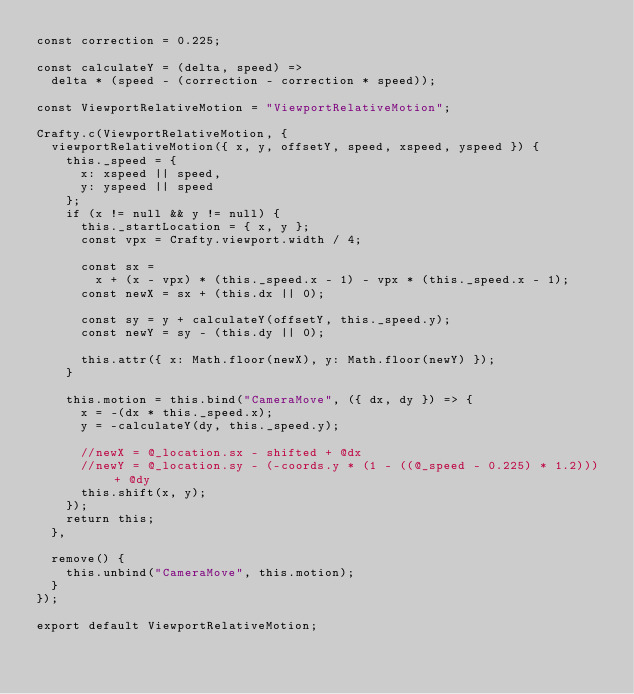<code> <loc_0><loc_0><loc_500><loc_500><_JavaScript_>const correction = 0.225;

const calculateY = (delta, speed) =>
  delta * (speed - (correction - correction * speed));

const ViewportRelativeMotion = "ViewportRelativeMotion";

Crafty.c(ViewportRelativeMotion, {
  viewportRelativeMotion({ x, y, offsetY, speed, xspeed, yspeed }) {
    this._speed = {
      x: xspeed || speed,
      y: yspeed || speed
    };
    if (x != null && y != null) {
      this._startLocation = { x, y };
      const vpx = Crafty.viewport.width / 4;

      const sx =
        x + (x - vpx) * (this._speed.x - 1) - vpx * (this._speed.x - 1);
      const newX = sx + (this.dx || 0);

      const sy = y + calculateY(offsetY, this._speed.y);
      const newY = sy - (this.dy || 0);

      this.attr({ x: Math.floor(newX), y: Math.floor(newY) });
    }

    this.motion = this.bind("CameraMove", ({ dx, dy }) => {
      x = -(dx * this._speed.x);
      y = -calculateY(dy, this._speed.y);

      //newX = @_location.sx - shifted + @dx
      //newY = @_location.sy - (-coords.y * (1 - ((@_speed - 0.225) * 1.2))) + @dy
      this.shift(x, y);
    });
    return this;
  },

  remove() {
    this.unbind("CameraMove", this.motion);
  }
});

export default ViewportRelativeMotion;
</code> 